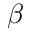<formula> <loc_0><loc_0><loc_500><loc_500>\beta</formula> 